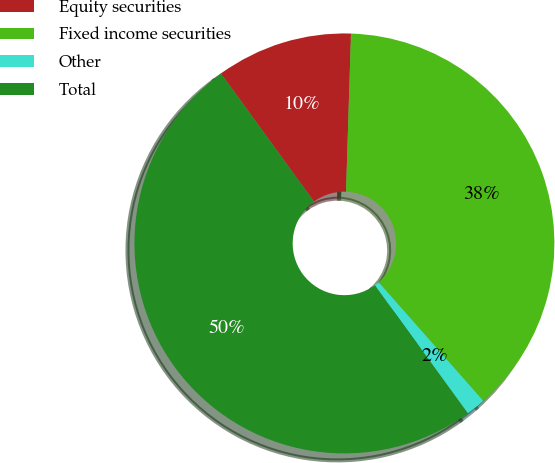<chart> <loc_0><loc_0><loc_500><loc_500><pie_chart><fcel>Equity securities<fcel>Fixed income securities<fcel>Other<fcel>Total<nl><fcel>10.5%<fcel>38.0%<fcel>1.5%<fcel>50.0%<nl></chart> 